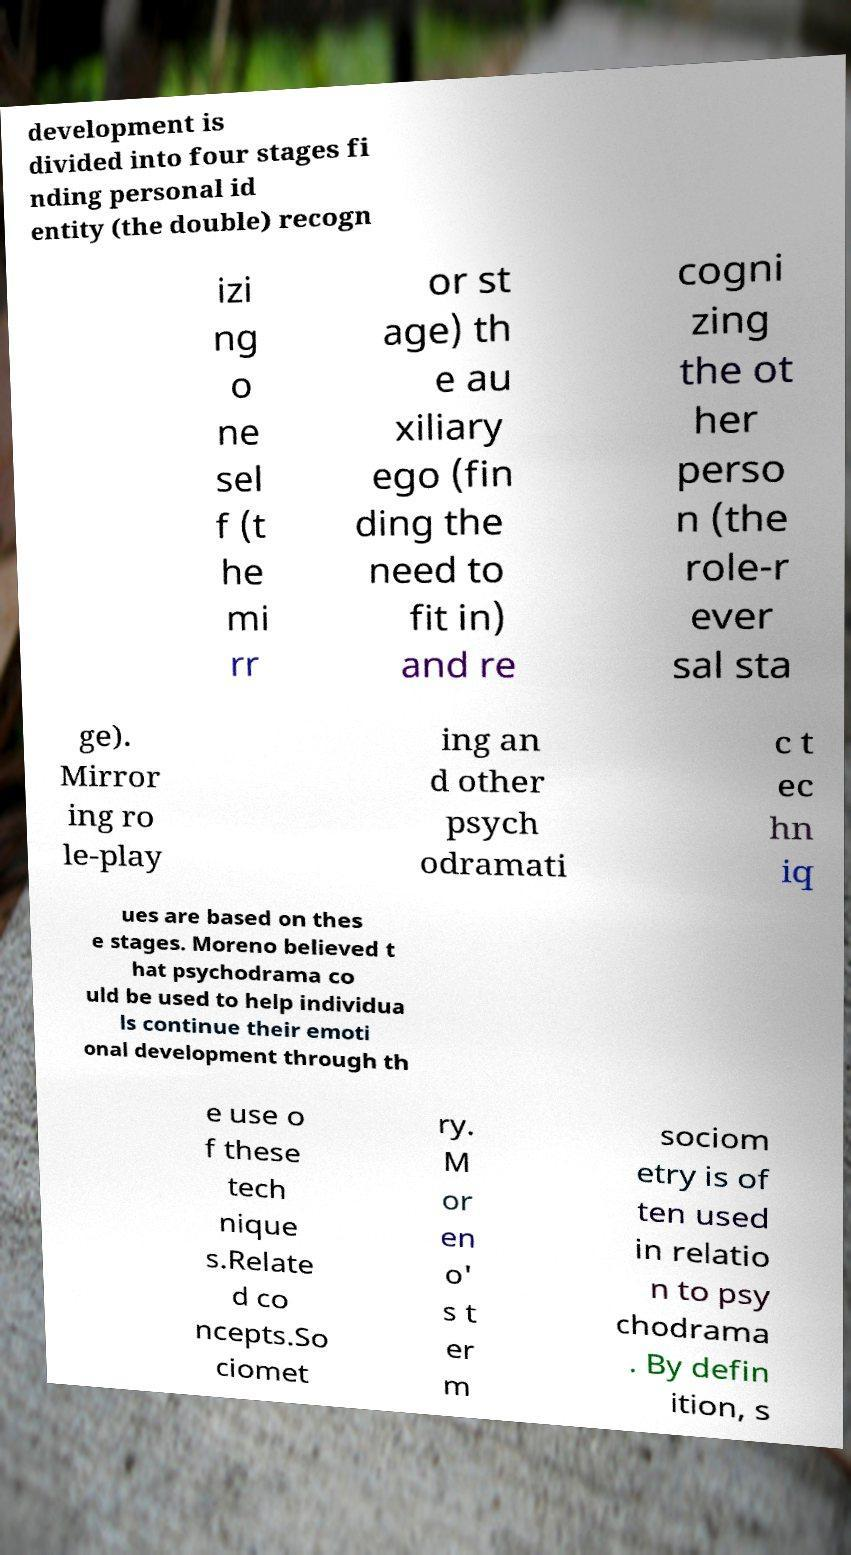Can you read and provide the text displayed in the image?This photo seems to have some interesting text. Can you extract and type it out for me? development is divided into four stages fi nding personal id entity (the double) recogn izi ng o ne sel f (t he mi rr or st age) th e au xiliary ego (fin ding the need to fit in) and re cogni zing the ot her perso n (the role-r ever sal sta ge). Mirror ing ro le-play ing an d other psych odramati c t ec hn iq ues are based on thes e stages. Moreno believed t hat psychodrama co uld be used to help individua ls continue their emoti onal development through th e use o f these tech nique s.Relate d co ncepts.So ciomet ry. M or en o' s t er m sociom etry is of ten used in relatio n to psy chodrama . By defin ition, s 